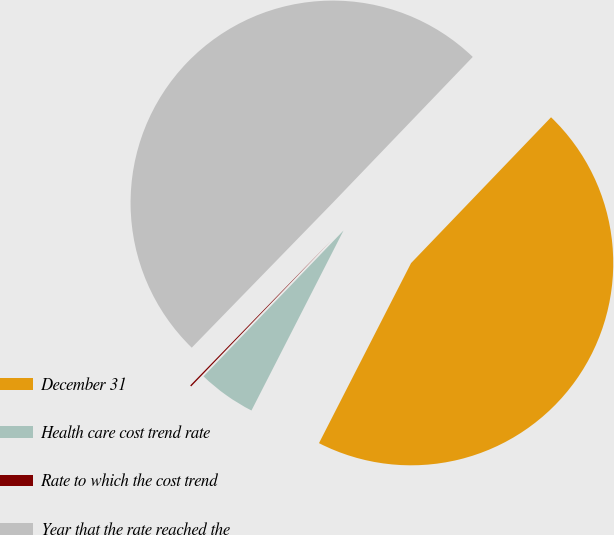Convert chart. <chart><loc_0><loc_0><loc_500><loc_500><pie_chart><fcel>December 31<fcel>Health care cost trend rate<fcel>Rate to which the cost trend<fcel>Year that the rate reached the<nl><fcel>45.35%<fcel>4.65%<fcel>0.11%<fcel>49.89%<nl></chart> 